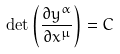<formula> <loc_0><loc_0><loc_500><loc_500>\det \left ( \frac { \partial y ^ { \alpha } } { \partial x ^ { \mu } } \right ) = C</formula> 